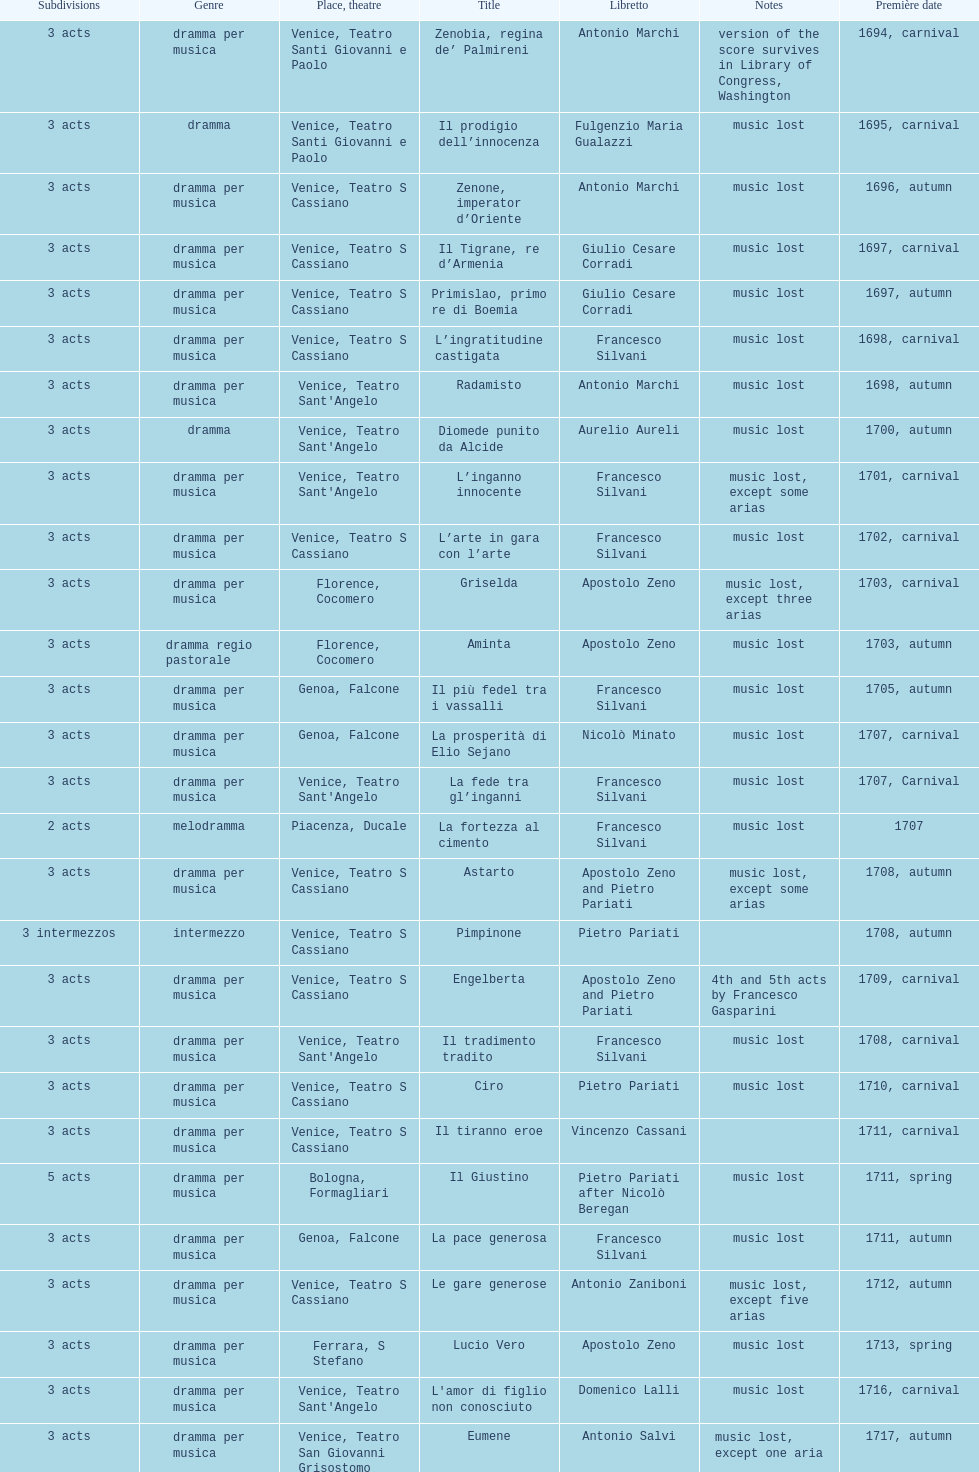Which opera has the most acts, la fortezza al cimento or astarto? Astarto. 